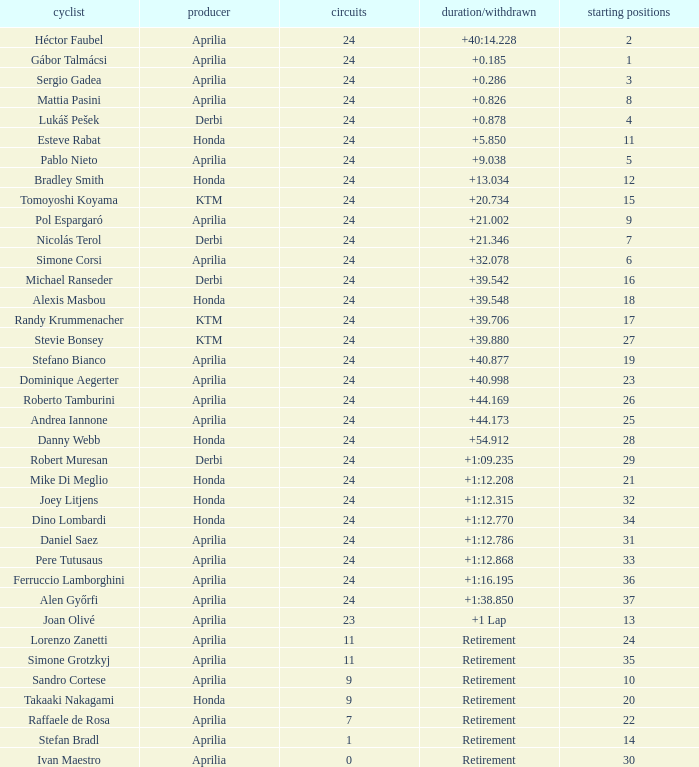How many grids correspond to more than 24 laps? None. 